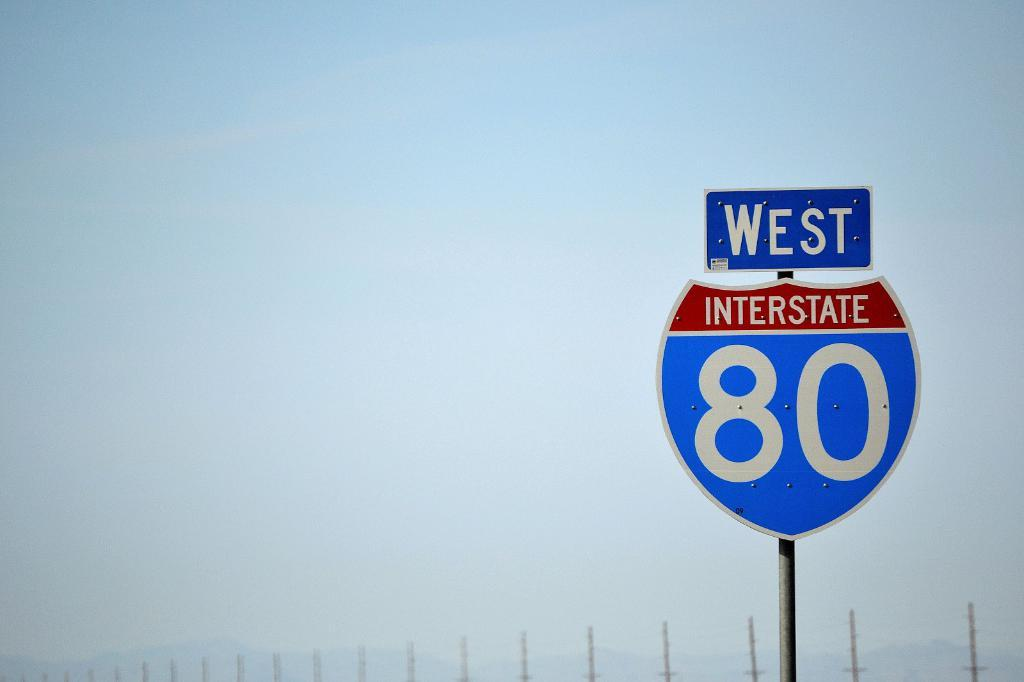Provide a one-sentence caption for the provided image. west interstate 80 sign on an overcast day. 